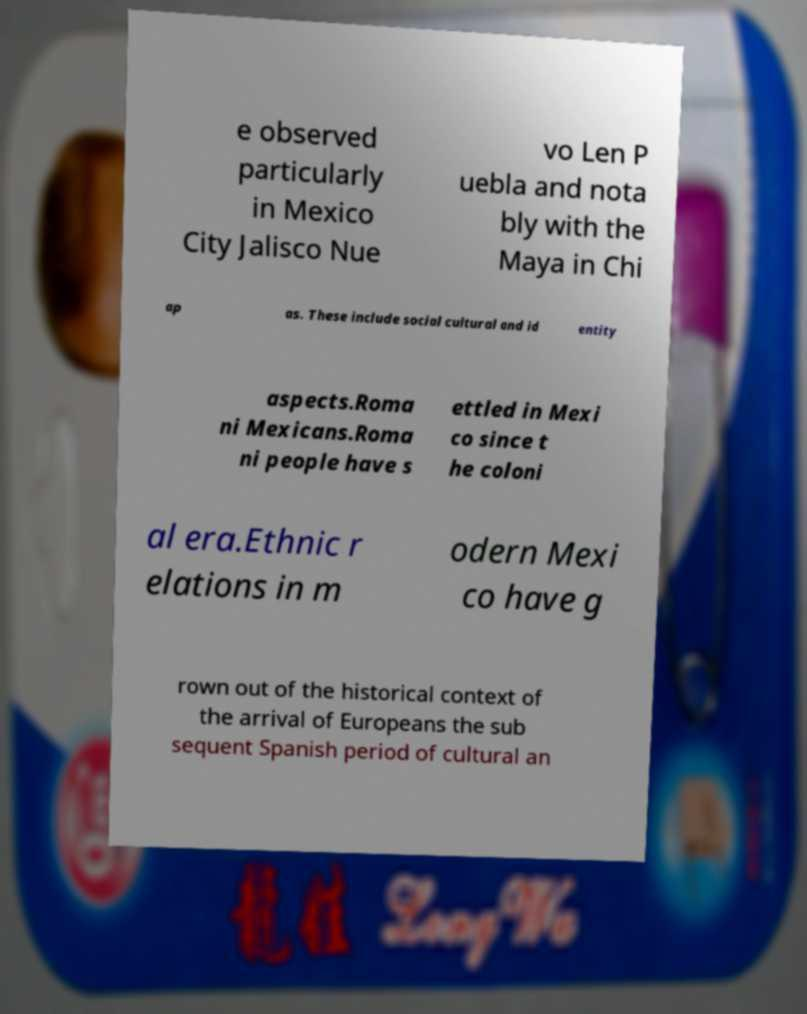Please identify and transcribe the text found in this image. e observed particularly in Mexico City Jalisco Nue vo Len P uebla and nota bly with the Maya in Chi ap as. These include social cultural and id entity aspects.Roma ni Mexicans.Roma ni people have s ettled in Mexi co since t he coloni al era.Ethnic r elations in m odern Mexi co have g rown out of the historical context of the arrival of Europeans the sub sequent Spanish period of cultural an 